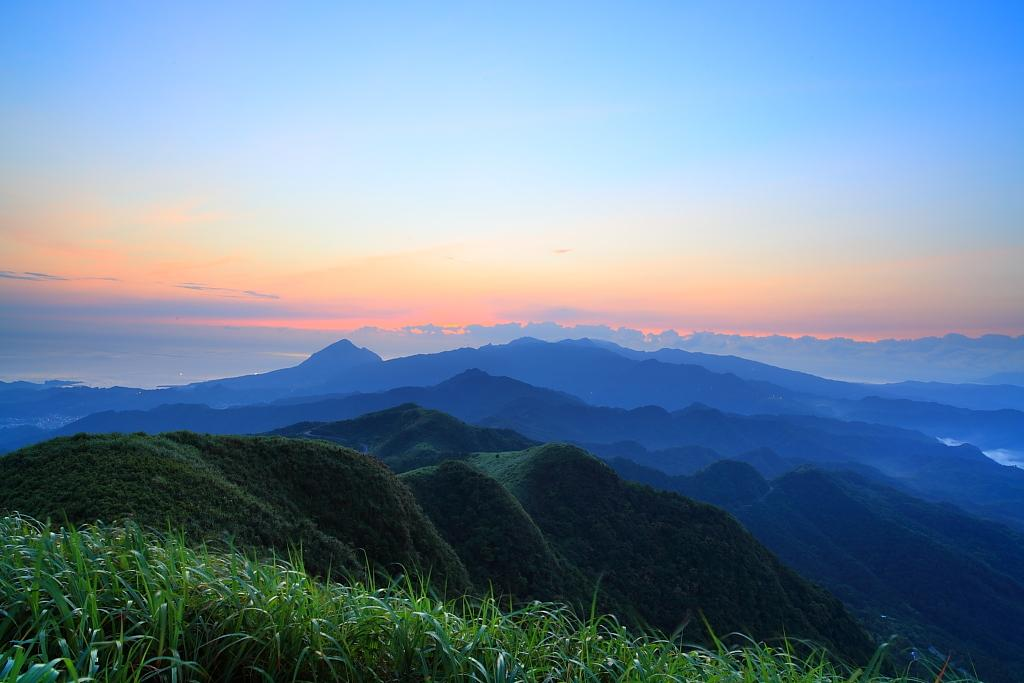What type of natural landscape is depicted in the image? The image contains mountains. What type of vegetation is present at the bottom of the image? There is grass at the bottom of the image. What part of the natural environment is visible in the image? The sky is visible at the top of the image. What type of effect does the mitten have on the mountains in the image? There is no mitten present in the image, so it is not possible to determine any effect it might have on the mountains. 